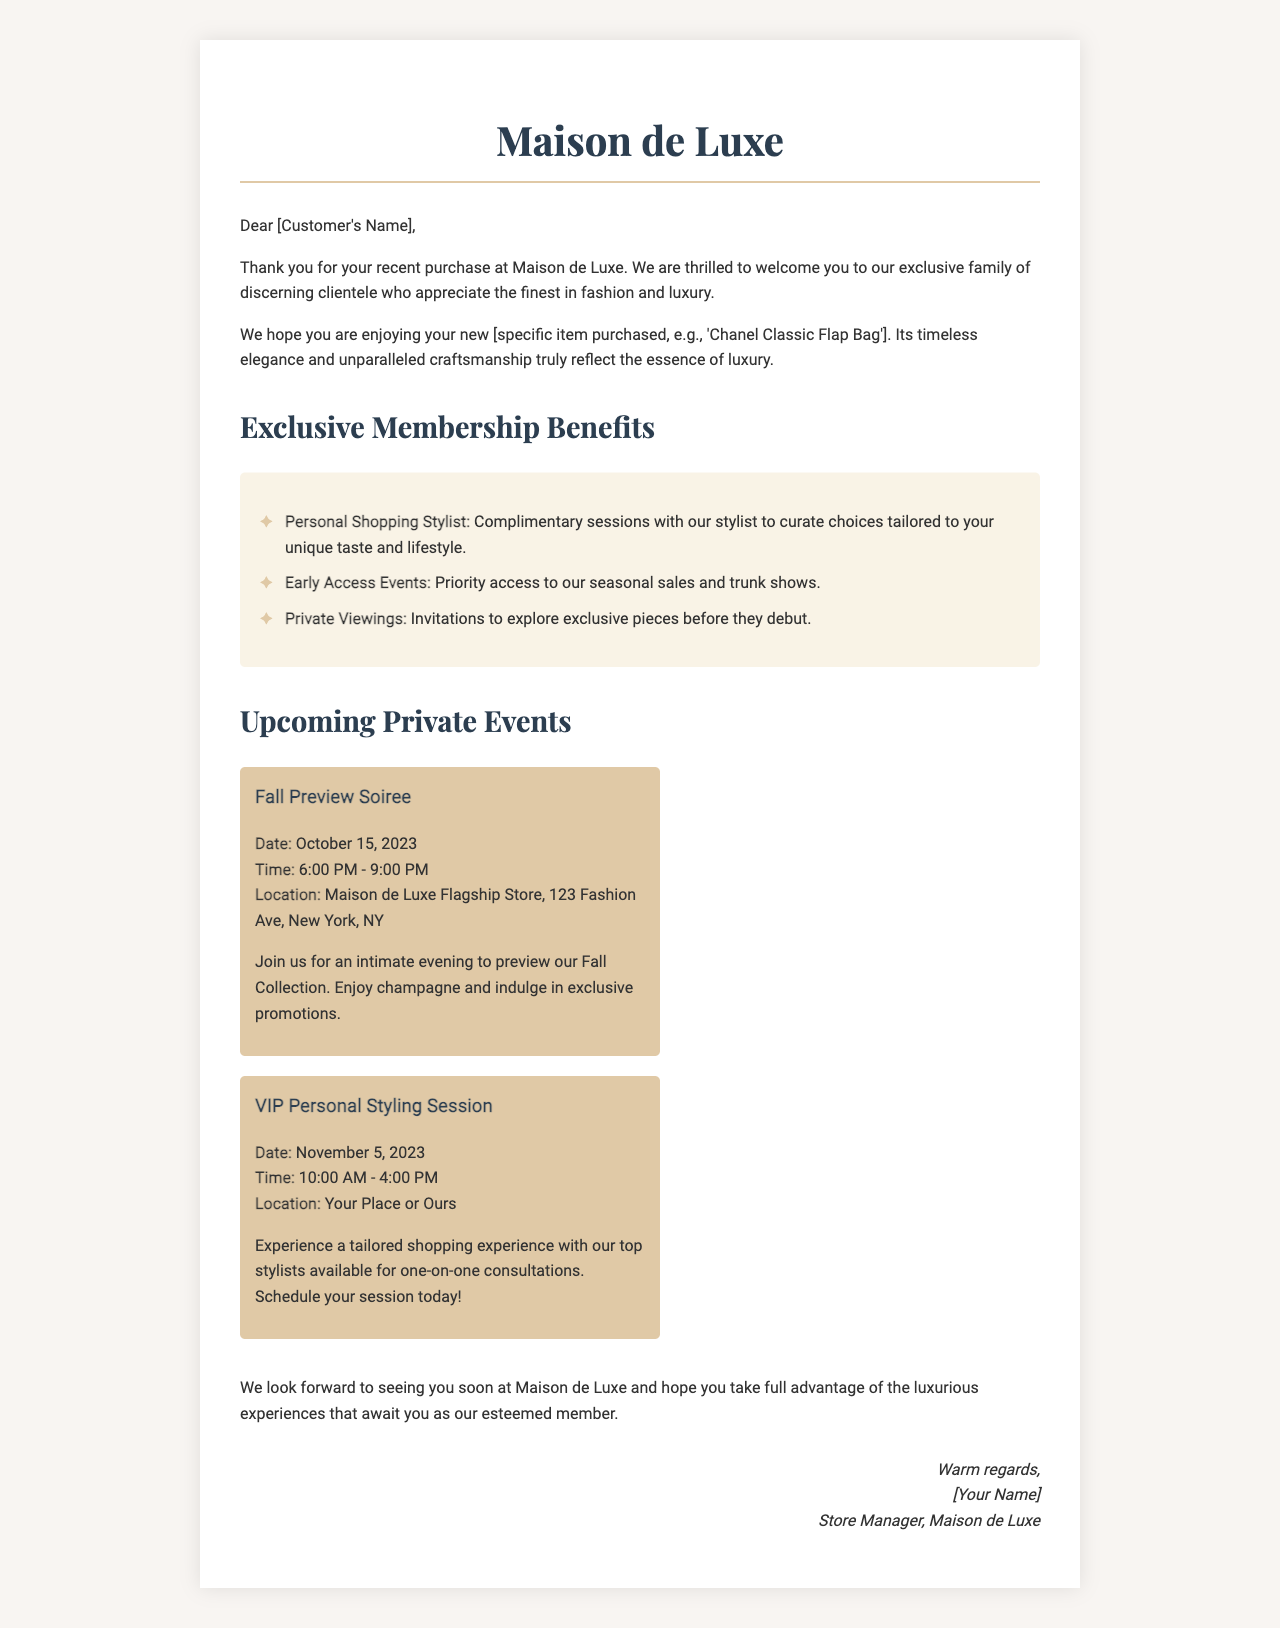What is the name of the boutique? The boutique is referred to as "Maison de Luxe" in the document.
Answer: Maison de Luxe What is the purchase mentioned in the letter? The letter refers to a specific item purchased, noted as "Chanel Classic Flap Bag."
Answer: Chanel Classic Flap Bag What is the date of the Fall Preview Soiree? The document specifies October 15, 2023, as the date for the Fall Preview Soiree.
Answer: October 15, 2023 What benefit allows personal stylist consultations? The document mentions "Personal Shopping Stylist" as a benefit that provides complimentary sessions with a stylist.
Answer: Personal Shopping Stylist What time does the VIP Personal Styling Session start? The document indicates that the VIP Personal Styling Session starts at 10:00 AM.
Answer: 10:00 AM How many exclusive benefits are listed in the letter? The document lists three exclusive benefits under the membership section.
Answer: Three Who is the sender of the letter? The letter is signed by the Store Manager of Maison de Luxe, although the name is represented as "[Your Name]."
Answer: [Your Name] What is the location of the Fall Preview Soiree? The document specifies that the event takes place at "Maison de Luxe Flagship Store, 123 Fashion Ave, New York, NY."
Answer: Maison de Luxe Flagship Store, 123 Fashion Ave, New York, NY 